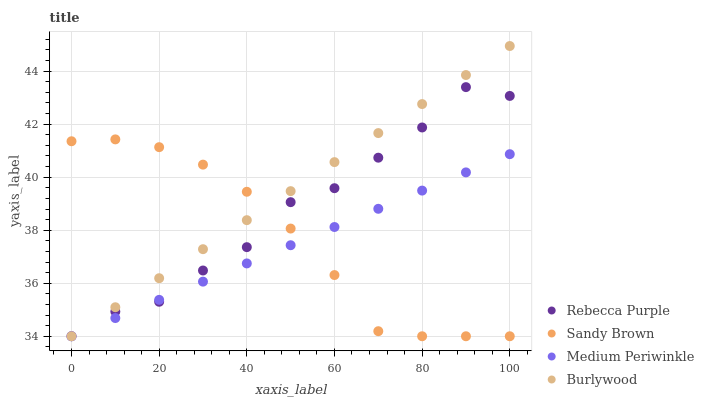Does Medium Periwinkle have the minimum area under the curve?
Answer yes or no. Yes. Does Burlywood have the maximum area under the curve?
Answer yes or no. Yes. Does Sandy Brown have the minimum area under the curve?
Answer yes or no. No. Does Sandy Brown have the maximum area under the curve?
Answer yes or no. No. Is Medium Periwinkle the smoothest?
Answer yes or no. Yes. Is Rebecca Purple the roughest?
Answer yes or no. Yes. Is Sandy Brown the smoothest?
Answer yes or no. No. Is Sandy Brown the roughest?
Answer yes or no. No. Does Burlywood have the lowest value?
Answer yes or no. Yes. Does Burlywood have the highest value?
Answer yes or no. Yes. Does Sandy Brown have the highest value?
Answer yes or no. No. Does Medium Periwinkle intersect Sandy Brown?
Answer yes or no. Yes. Is Medium Periwinkle less than Sandy Brown?
Answer yes or no. No. Is Medium Periwinkle greater than Sandy Brown?
Answer yes or no. No. 